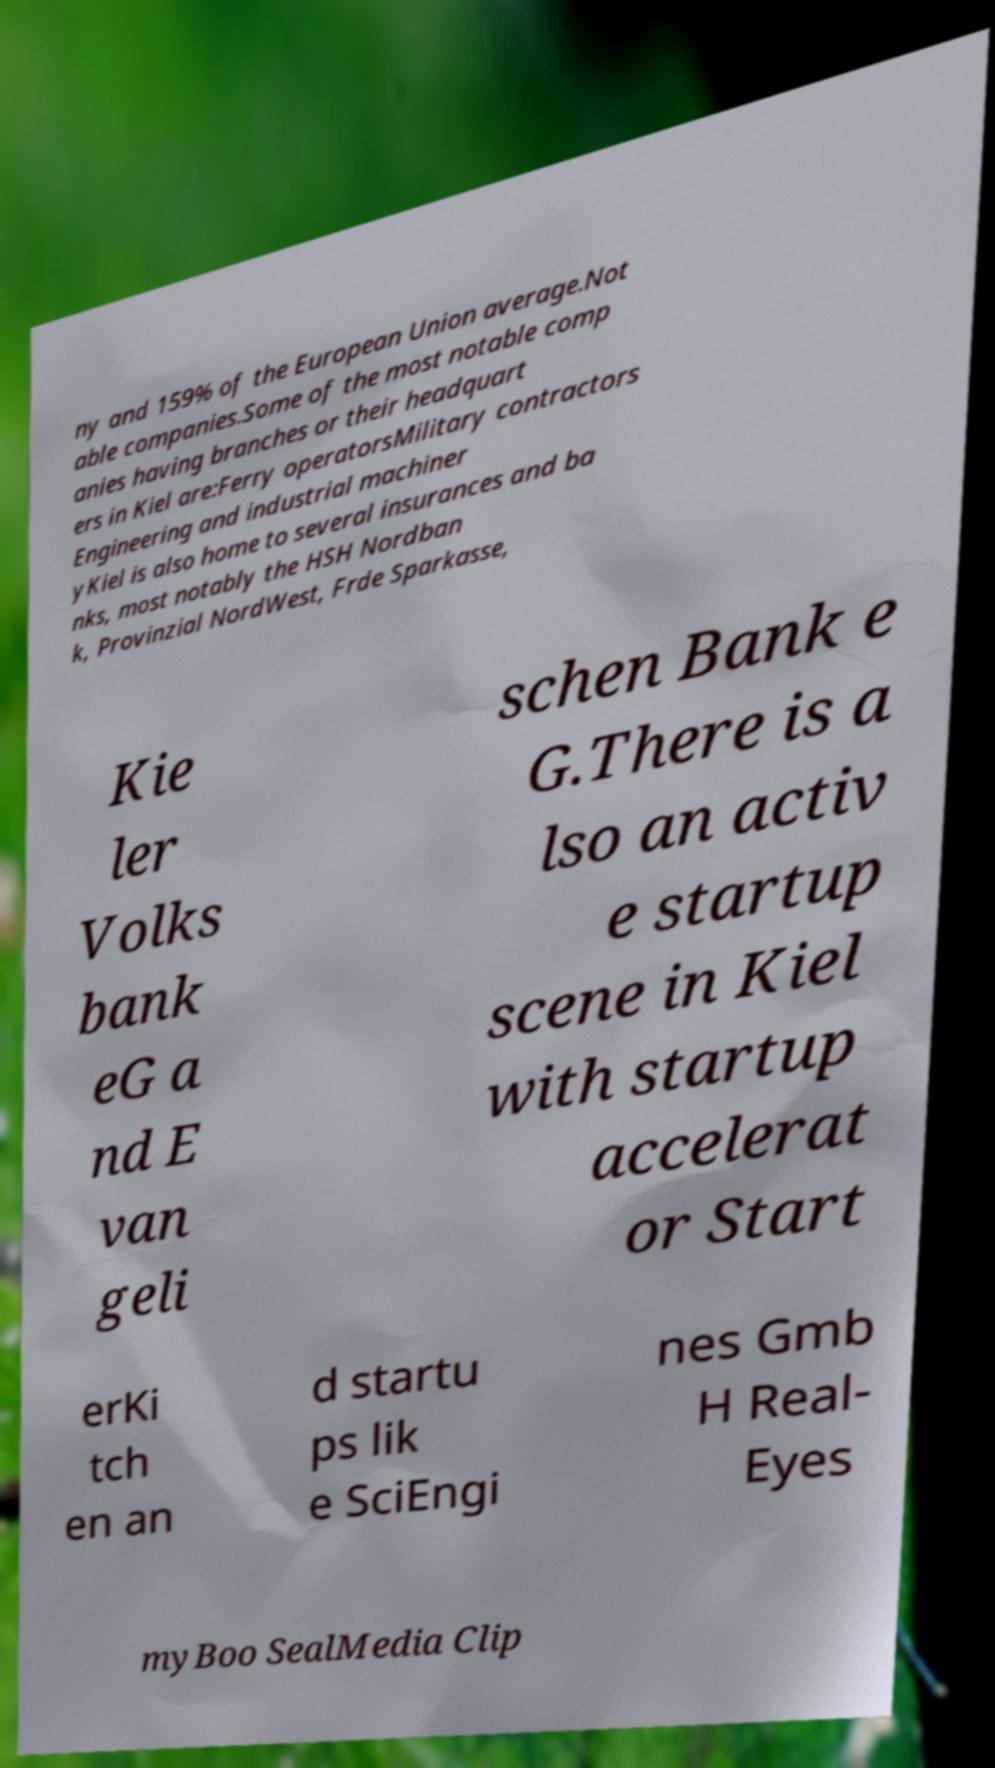Can you read and provide the text displayed in the image?This photo seems to have some interesting text. Can you extract and type it out for me? ny and 159% of the European Union average.Not able companies.Some of the most notable comp anies having branches or their headquart ers in Kiel are:Ferry operatorsMilitary contractors Engineering and industrial machiner yKiel is also home to several insurances and ba nks, most notably the HSH Nordban k, Provinzial NordWest, Frde Sparkasse, Kie ler Volks bank eG a nd E van geli schen Bank e G.There is a lso an activ e startup scene in Kiel with startup accelerat or Start erKi tch en an d startu ps lik e SciEngi nes Gmb H Real- Eyes myBoo SealMedia Clip 